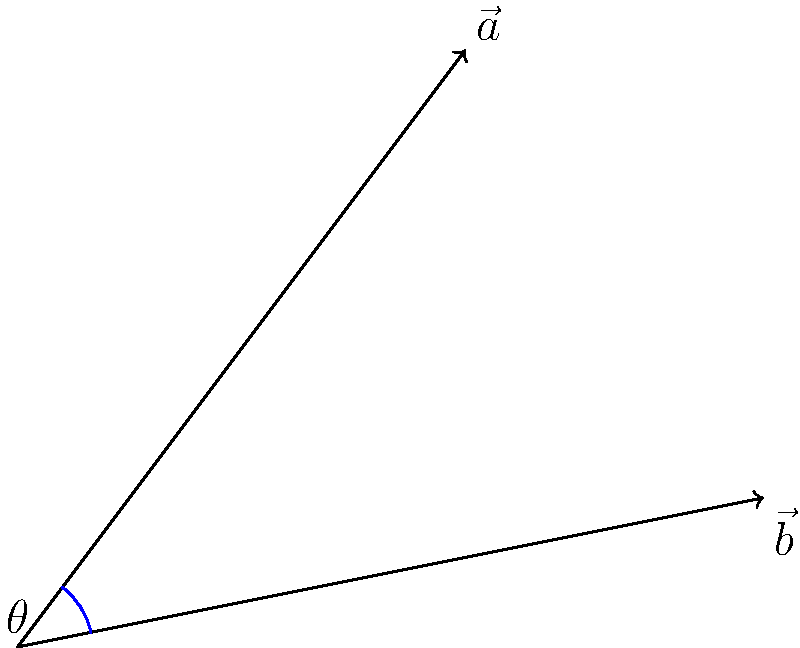In a scene for your upcoming movie, you and Deanna Yusoff are walking in different directions. Your path is represented by vector $\vec{a} = 3\hat{i} + 4\hat{j}$, while Deanna's path is represented by vector $\vec{b} = 5\hat{i} + \hat{j}$. What is the angle between your paths? To find the angle between two vectors, we can use the dot product formula:

$$\cos \theta = \frac{\vec{a} \cdot \vec{b}}{|\vec{a}||\vec{b}|}$$

Step 1: Calculate the dot product $\vec{a} \cdot \vec{b}$
$$\vec{a} \cdot \vec{b} = (3)(5) + (4)(1) = 15 + 4 = 19$$

Step 2: Calculate the magnitudes of $\vec{a}$ and $\vec{b}$
$$|\vec{a}| = \sqrt{3^2 + 4^2} = \sqrt{9 + 16} = \sqrt{25} = 5$$
$$|\vec{b}| = \sqrt{5^2 + 1^2} = \sqrt{25 + 1} = \sqrt{26}$$

Step 3: Substitute into the formula
$$\cos \theta = \frac{19}{5\sqrt{26}}$$

Step 4: Take the inverse cosine (arccos) of both sides
$$\theta = \arccos(\frac{19}{5\sqrt{26}})$$

Step 5: Calculate the result (using a calculator)
$$\theta \approx 0.5095 \text{ radians}$$

Step 6: Convert to degrees
$$\theta \approx 0.5095 \times \frac{180}{\pi} \approx 29.2°$$
Answer: $29.2°$ 